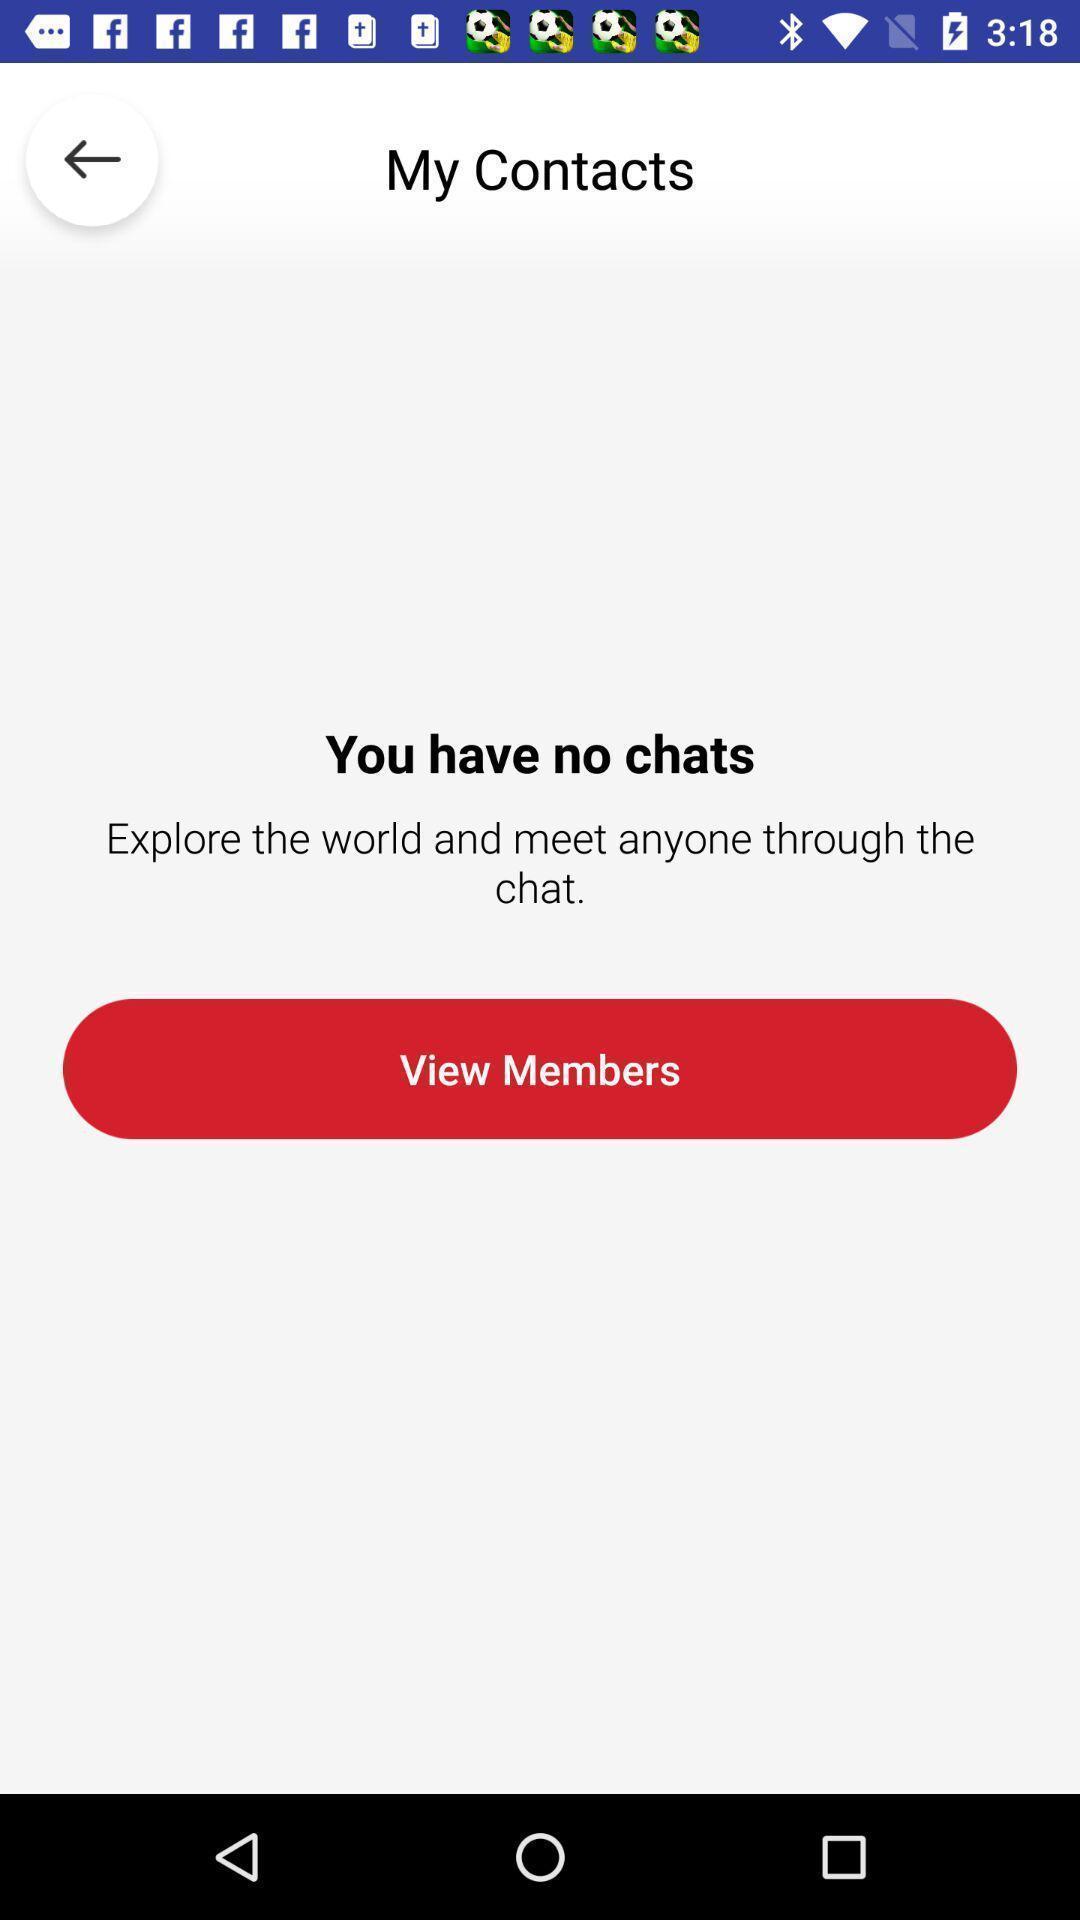Tell me about the visual elements in this screen capture. Screen shows view member option in a chat app. 